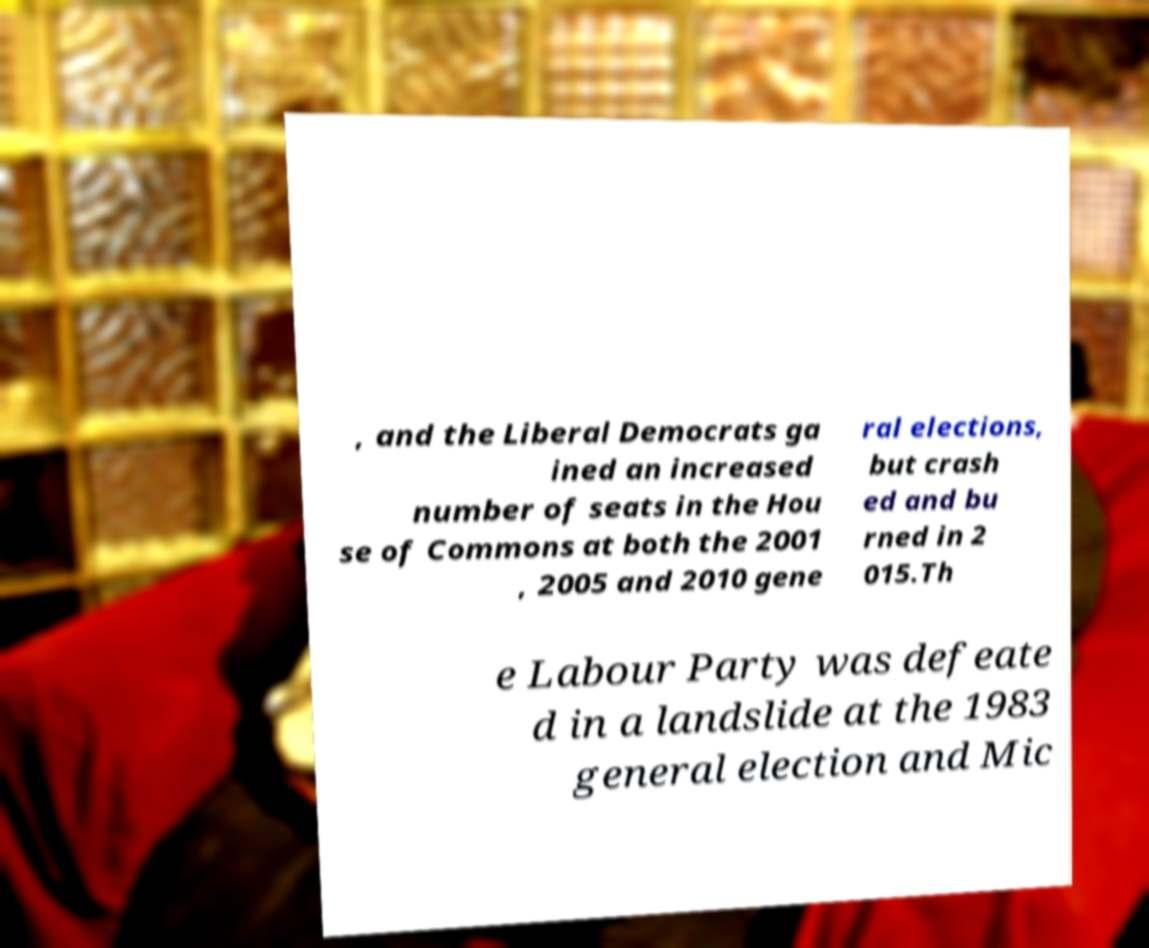Could you assist in decoding the text presented in this image and type it out clearly? , and the Liberal Democrats ga ined an increased number of seats in the Hou se of Commons at both the 2001 , 2005 and 2010 gene ral elections, but crash ed and bu rned in 2 015.Th e Labour Party was defeate d in a landslide at the 1983 general election and Mic 